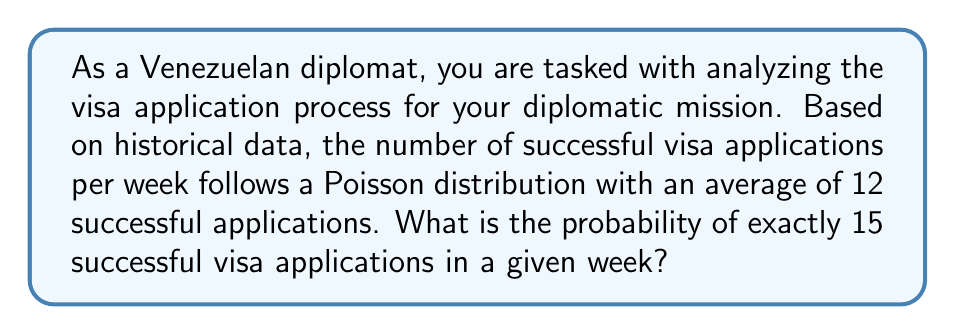Show me your answer to this math problem. Let's approach this step-by-step:

1) The Poisson distribution is given by the formula:

   $$P(X = k) = \frac{e^{-\lambda} \lambda^k}{k!}$$

   Where:
   - $\lambda$ is the average number of events in the given interval
   - $k$ is the number of events we're calculating the probability for
   - $e$ is Euler's number (approximately 2.71828)

2) In this case:
   - $\lambda = 12$ (average number of successful applications per week)
   - $k = 15$ (we're calculating the probability of exactly 15 successful applications)

3) Let's substitute these values into the formula:

   $$P(X = 15) = \frac{e^{-12} 12^{15}}{15!}$$

4) Now, let's calculate this step-by-step:
   
   a) First, calculate $e^{-12}$:
      $e^{-12} \approx 6.14421 \times 10^{-6}$

   b) Then, calculate $12^{15}$:
      $12^{15} = 7.18465 \times 10^{16}$

   c) Calculate 15!:
      $15! = 1,307,674,368,000$

   d) Now, put it all together:

      $$\frac{(6.14421 \times 10^{-6})(7.18465 \times 10^{16})}{1,307,674,368,000}$$

5) Simplifying this expression:

   $$\frac{4.41446 \times 10^{11}}{1.30767 \times 10^{12}} \approx 0.33758$$

6) Therefore, the probability is approximately 0.33758 or about 33.76%.
Answer: $P(X = 15) \approx 0.33758$ or $33.76\%$ 